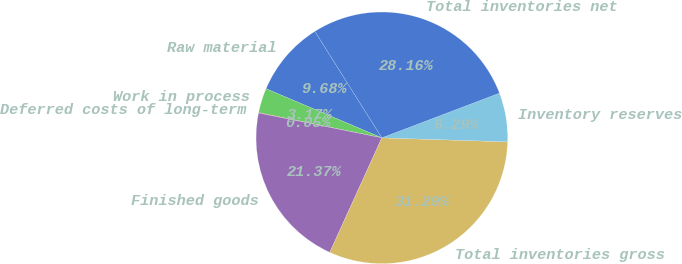Convert chart. <chart><loc_0><loc_0><loc_500><loc_500><pie_chart><fcel>Raw material<fcel>Work in process<fcel>Deferred costs of long-term<fcel>Finished goods<fcel>Total inventories gross<fcel>Inventory reserves<fcel>Total inventories net<nl><fcel>9.68%<fcel>3.17%<fcel>0.05%<fcel>21.37%<fcel>31.29%<fcel>6.29%<fcel>28.16%<nl></chart> 